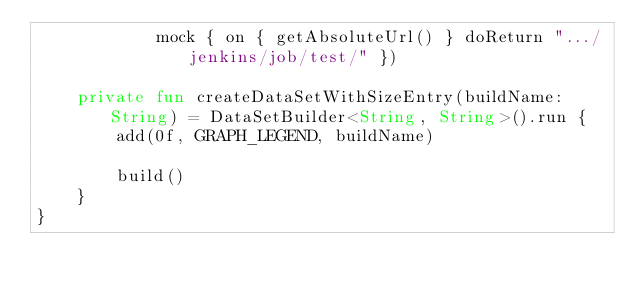Convert code to text. <code><loc_0><loc_0><loc_500><loc_500><_Kotlin_>            mock { on { getAbsoluteUrl() } doReturn ".../jenkins/job/test/" })

    private fun createDataSetWithSizeEntry(buildName: String) = DataSetBuilder<String, String>().run {
        add(0f, GRAPH_LEGEND, buildName)

        build()
    }
}</code> 